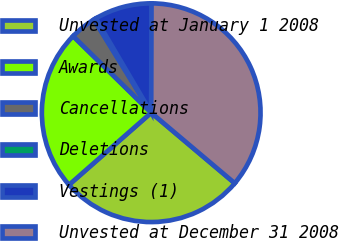<chart> <loc_0><loc_0><loc_500><loc_500><pie_chart><fcel>Unvested at January 1 2008<fcel>Awards<fcel>Cancellations<fcel>Deletions<fcel>Vestings (1)<fcel>Unvested at December 31 2008<nl><fcel>27.38%<fcel>23.81%<fcel>3.89%<fcel>0.31%<fcel>8.5%<fcel>36.11%<nl></chart> 